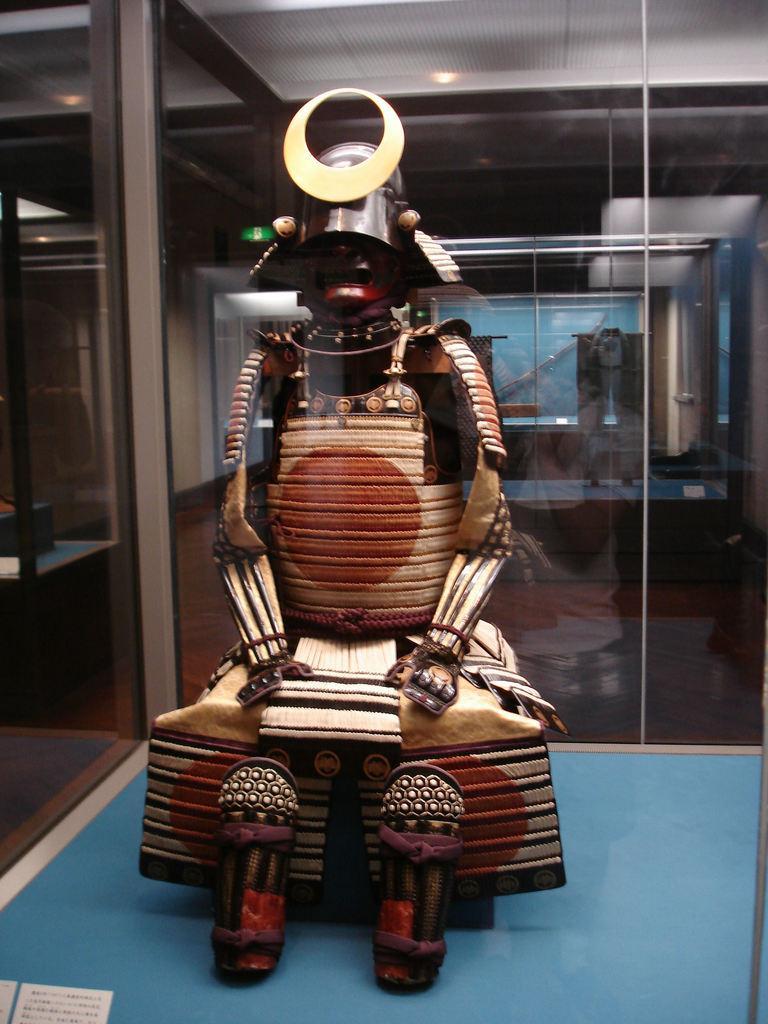How would you summarize this image in a sentence or two? In the image inside the glass there is a statue. Behind that there are few more statues inside the glass. 